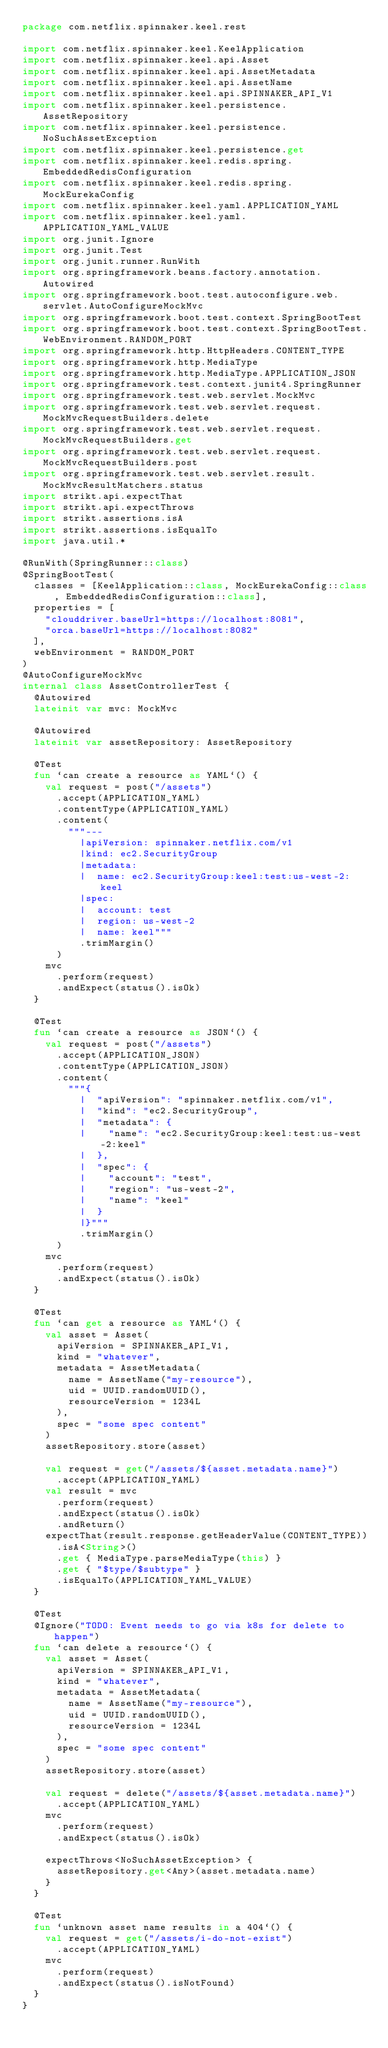Convert code to text. <code><loc_0><loc_0><loc_500><loc_500><_Kotlin_>package com.netflix.spinnaker.keel.rest

import com.netflix.spinnaker.keel.KeelApplication
import com.netflix.spinnaker.keel.api.Asset
import com.netflix.spinnaker.keel.api.AssetMetadata
import com.netflix.spinnaker.keel.api.AssetName
import com.netflix.spinnaker.keel.api.SPINNAKER_API_V1
import com.netflix.spinnaker.keel.persistence.AssetRepository
import com.netflix.spinnaker.keel.persistence.NoSuchAssetException
import com.netflix.spinnaker.keel.persistence.get
import com.netflix.spinnaker.keel.redis.spring.EmbeddedRedisConfiguration
import com.netflix.spinnaker.keel.redis.spring.MockEurekaConfig
import com.netflix.spinnaker.keel.yaml.APPLICATION_YAML
import com.netflix.spinnaker.keel.yaml.APPLICATION_YAML_VALUE
import org.junit.Ignore
import org.junit.Test
import org.junit.runner.RunWith
import org.springframework.beans.factory.annotation.Autowired
import org.springframework.boot.test.autoconfigure.web.servlet.AutoConfigureMockMvc
import org.springframework.boot.test.context.SpringBootTest
import org.springframework.boot.test.context.SpringBootTest.WebEnvironment.RANDOM_PORT
import org.springframework.http.HttpHeaders.CONTENT_TYPE
import org.springframework.http.MediaType
import org.springframework.http.MediaType.APPLICATION_JSON
import org.springframework.test.context.junit4.SpringRunner
import org.springframework.test.web.servlet.MockMvc
import org.springframework.test.web.servlet.request.MockMvcRequestBuilders.delete
import org.springframework.test.web.servlet.request.MockMvcRequestBuilders.get
import org.springframework.test.web.servlet.request.MockMvcRequestBuilders.post
import org.springframework.test.web.servlet.result.MockMvcResultMatchers.status
import strikt.api.expectThat
import strikt.api.expectThrows
import strikt.assertions.isA
import strikt.assertions.isEqualTo
import java.util.*

@RunWith(SpringRunner::class)
@SpringBootTest(
  classes = [KeelApplication::class, MockEurekaConfig::class, EmbeddedRedisConfiguration::class],
  properties = [
    "clouddriver.baseUrl=https://localhost:8081",
    "orca.baseUrl=https://localhost:8082"
  ],
  webEnvironment = RANDOM_PORT
)
@AutoConfigureMockMvc
internal class AssetControllerTest {
  @Autowired
  lateinit var mvc: MockMvc

  @Autowired
  lateinit var assetRepository: AssetRepository

  @Test
  fun `can create a resource as YAML`() {
    val request = post("/assets")
      .accept(APPLICATION_YAML)
      .contentType(APPLICATION_YAML)
      .content(
        """---
          |apiVersion: spinnaker.netflix.com/v1
          |kind: ec2.SecurityGroup
          |metadata:
          |  name: ec2.SecurityGroup:keel:test:us-west-2:keel
          |spec:
          |  account: test
          |  region: us-west-2
          |  name: keel"""
          .trimMargin()
      )
    mvc
      .perform(request)
      .andExpect(status().isOk)
  }

  @Test
  fun `can create a resource as JSON`() {
    val request = post("/assets")
      .accept(APPLICATION_JSON)
      .contentType(APPLICATION_JSON)
      .content(
        """{
          |  "apiVersion": "spinnaker.netflix.com/v1",
          |  "kind": "ec2.SecurityGroup",
          |  "metadata": {
          |    "name": "ec2.SecurityGroup:keel:test:us-west-2:keel"
          |  },
          |  "spec": {
          |    "account": "test",
          |    "region": "us-west-2",
          |    "name": "keel"
          |  }
          |}"""
          .trimMargin()
      )
    mvc
      .perform(request)
      .andExpect(status().isOk)
  }

  @Test
  fun `can get a resource as YAML`() {
    val asset = Asset(
      apiVersion = SPINNAKER_API_V1,
      kind = "whatever",
      metadata = AssetMetadata(
        name = AssetName("my-resource"),
        uid = UUID.randomUUID(),
        resourceVersion = 1234L
      ),
      spec = "some spec content"
    )
    assetRepository.store(asset)

    val request = get("/assets/${asset.metadata.name}")
      .accept(APPLICATION_YAML)
    val result = mvc
      .perform(request)
      .andExpect(status().isOk)
      .andReturn()
    expectThat(result.response.getHeaderValue(CONTENT_TYPE))
      .isA<String>()
      .get { MediaType.parseMediaType(this) }
      .get { "$type/$subtype" }
      .isEqualTo(APPLICATION_YAML_VALUE)
  }

  @Test
  @Ignore("TODO: Event needs to go via k8s for delete to happen")
  fun `can delete a resource`() {
    val asset = Asset(
      apiVersion = SPINNAKER_API_V1,
      kind = "whatever",
      metadata = AssetMetadata(
        name = AssetName("my-resource"),
        uid = UUID.randomUUID(),
        resourceVersion = 1234L
      ),
      spec = "some spec content"
    )
    assetRepository.store(asset)

    val request = delete("/assets/${asset.metadata.name}")
      .accept(APPLICATION_YAML)
    mvc
      .perform(request)
      .andExpect(status().isOk)

    expectThrows<NoSuchAssetException> {
      assetRepository.get<Any>(asset.metadata.name)
    }
  }

  @Test
  fun `unknown asset name results in a 404`() {
    val request = get("/assets/i-do-not-exist")
      .accept(APPLICATION_YAML)
    mvc
      .perform(request)
      .andExpect(status().isNotFound)
  }
}
</code> 